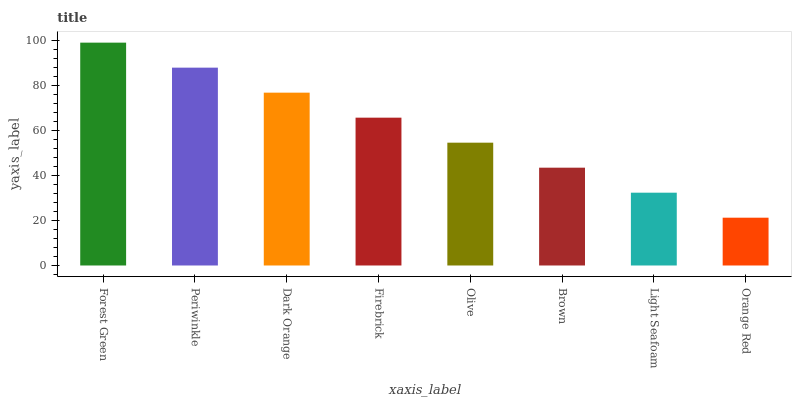Is Orange Red the minimum?
Answer yes or no. Yes. Is Forest Green the maximum?
Answer yes or no. Yes. Is Periwinkle the minimum?
Answer yes or no. No. Is Periwinkle the maximum?
Answer yes or no. No. Is Forest Green greater than Periwinkle?
Answer yes or no. Yes. Is Periwinkle less than Forest Green?
Answer yes or no. Yes. Is Periwinkle greater than Forest Green?
Answer yes or no. No. Is Forest Green less than Periwinkle?
Answer yes or no. No. Is Firebrick the high median?
Answer yes or no. Yes. Is Olive the low median?
Answer yes or no. Yes. Is Light Seafoam the high median?
Answer yes or no. No. Is Brown the low median?
Answer yes or no. No. 